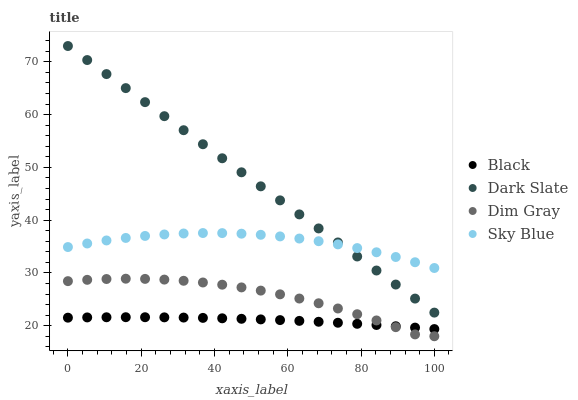Does Black have the minimum area under the curve?
Answer yes or no. Yes. Does Dark Slate have the maximum area under the curve?
Answer yes or no. Yes. Does Dim Gray have the minimum area under the curve?
Answer yes or no. No. Does Dim Gray have the maximum area under the curve?
Answer yes or no. No. Is Dark Slate the smoothest?
Answer yes or no. Yes. Is Dim Gray the roughest?
Answer yes or no. Yes. Is Black the smoothest?
Answer yes or no. No. Is Black the roughest?
Answer yes or no. No. Does Dim Gray have the lowest value?
Answer yes or no. Yes. Does Black have the lowest value?
Answer yes or no. No. Does Dark Slate have the highest value?
Answer yes or no. Yes. Does Dim Gray have the highest value?
Answer yes or no. No. Is Dim Gray less than Dark Slate?
Answer yes or no. Yes. Is Sky Blue greater than Dim Gray?
Answer yes or no. Yes. Does Dark Slate intersect Sky Blue?
Answer yes or no. Yes. Is Dark Slate less than Sky Blue?
Answer yes or no. No. Is Dark Slate greater than Sky Blue?
Answer yes or no. No. Does Dim Gray intersect Dark Slate?
Answer yes or no. No. 